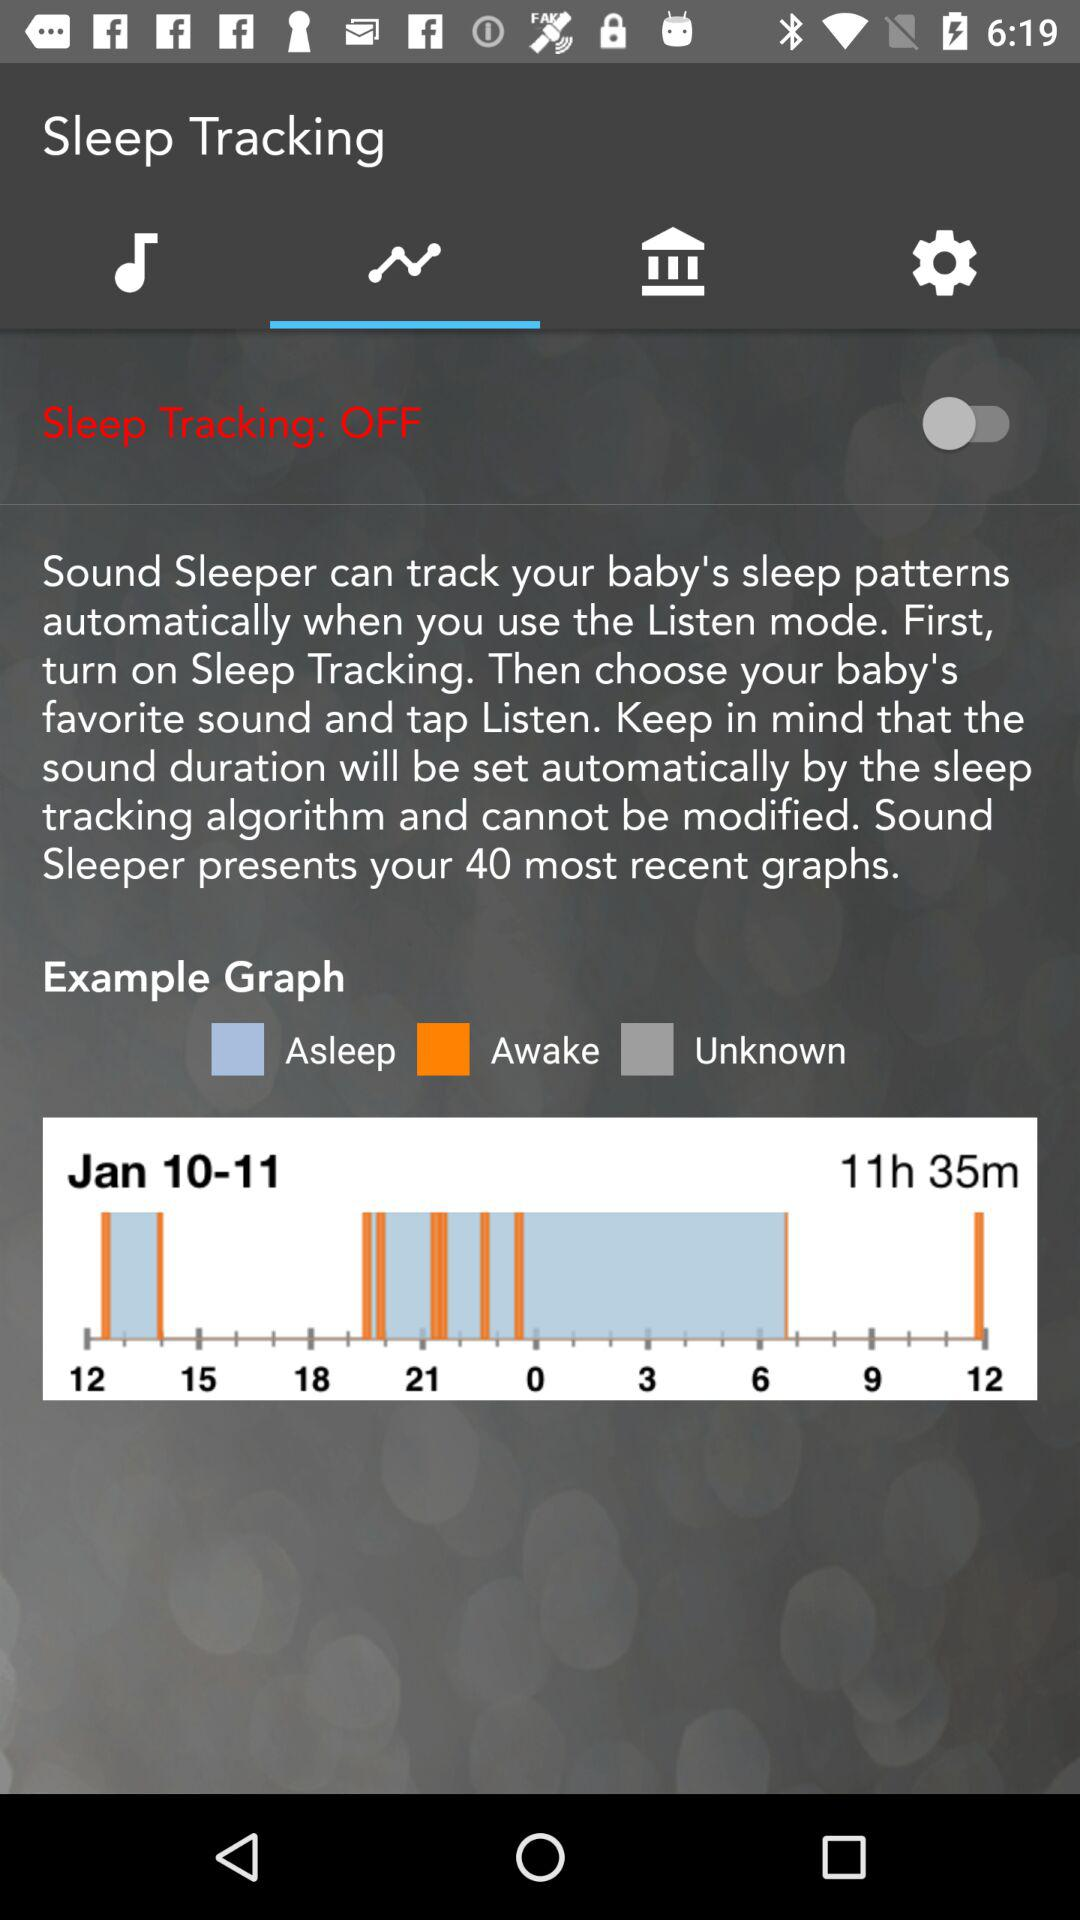What date is shown in the graph? The shown date is Jan 10-11. 